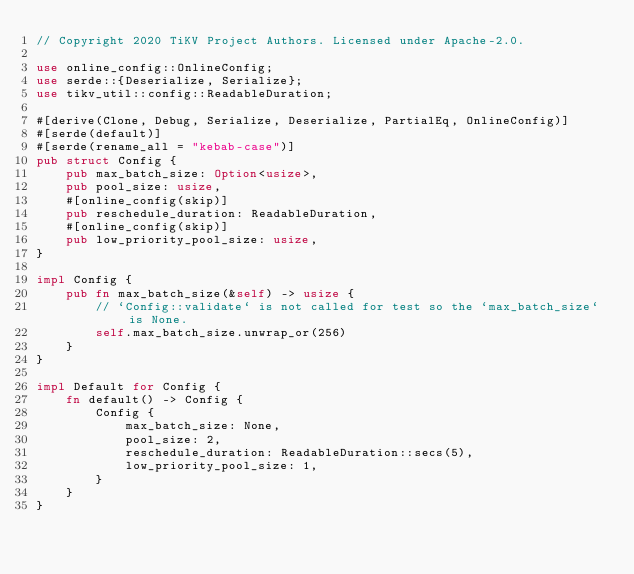<code> <loc_0><loc_0><loc_500><loc_500><_Rust_>// Copyright 2020 TiKV Project Authors. Licensed under Apache-2.0.

use online_config::OnlineConfig;
use serde::{Deserialize, Serialize};
use tikv_util::config::ReadableDuration;

#[derive(Clone, Debug, Serialize, Deserialize, PartialEq, OnlineConfig)]
#[serde(default)]
#[serde(rename_all = "kebab-case")]
pub struct Config {
    pub max_batch_size: Option<usize>,
    pub pool_size: usize,
    #[online_config(skip)]
    pub reschedule_duration: ReadableDuration,
    #[online_config(skip)]
    pub low_priority_pool_size: usize,
}

impl Config {
    pub fn max_batch_size(&self) -> usize {
        // `Config::validate` is not called for test so the `max_batch_size` is None.
        self.max_batch_size.unwrap_or(256)
    }
}

impl Default for Config {
    fn default() -> Config {
        Config {
            max_batch_size: None,
            pool_size: 2,
            reschedule_duration: ReadableDuration::secs(5),
            low_priority_pool_size: 1,
        }
    }
}
</code> 